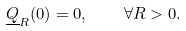<formula> <loc_0><loc_0><loc_500><loc_500>\underline { Q } _ { R } ( 0 ) = 0 , \quad \forall R > 0 .</formula> 